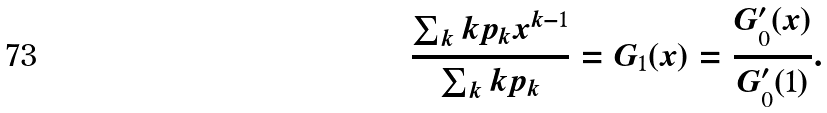<formula> <loc_0><loc_0><loc_500><loc_500>\frac { \sum _ { k } k p _ { k } x ^ { k - 1 } } { \sum _ { k } k p _ { k } } = G _ { 1 } ( x ) = \frac { G _ { 0 } ^ { \prime } ( x ) } { G _ { 0 } ^ { \prime } ( 1 ) } .</formula> 